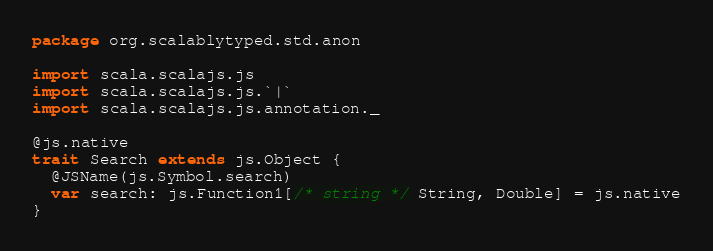Convert code to text. <code><loc_0><loc_0><loc_500><loc_500><_Scala_>package org.scalablytyped.std.anon

import scala.scalajs.js
import scala.scalajs.js.`|`
import scala.scalajs.js.annotation._

@js.native
trait Search extends js.Object {
  @JSName(js.Symbol.search)
  var search: js.Function1[/* string */ String, Double] = js.native
}

</code> 